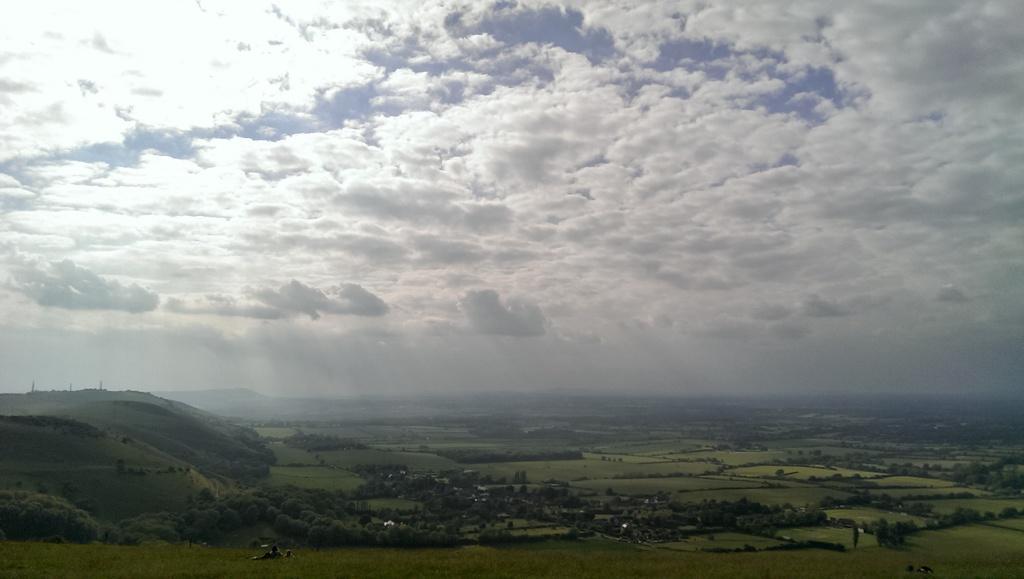Can you describe this image briefly? In this image we can see group of trees ,mountains and a cloudy sky. 